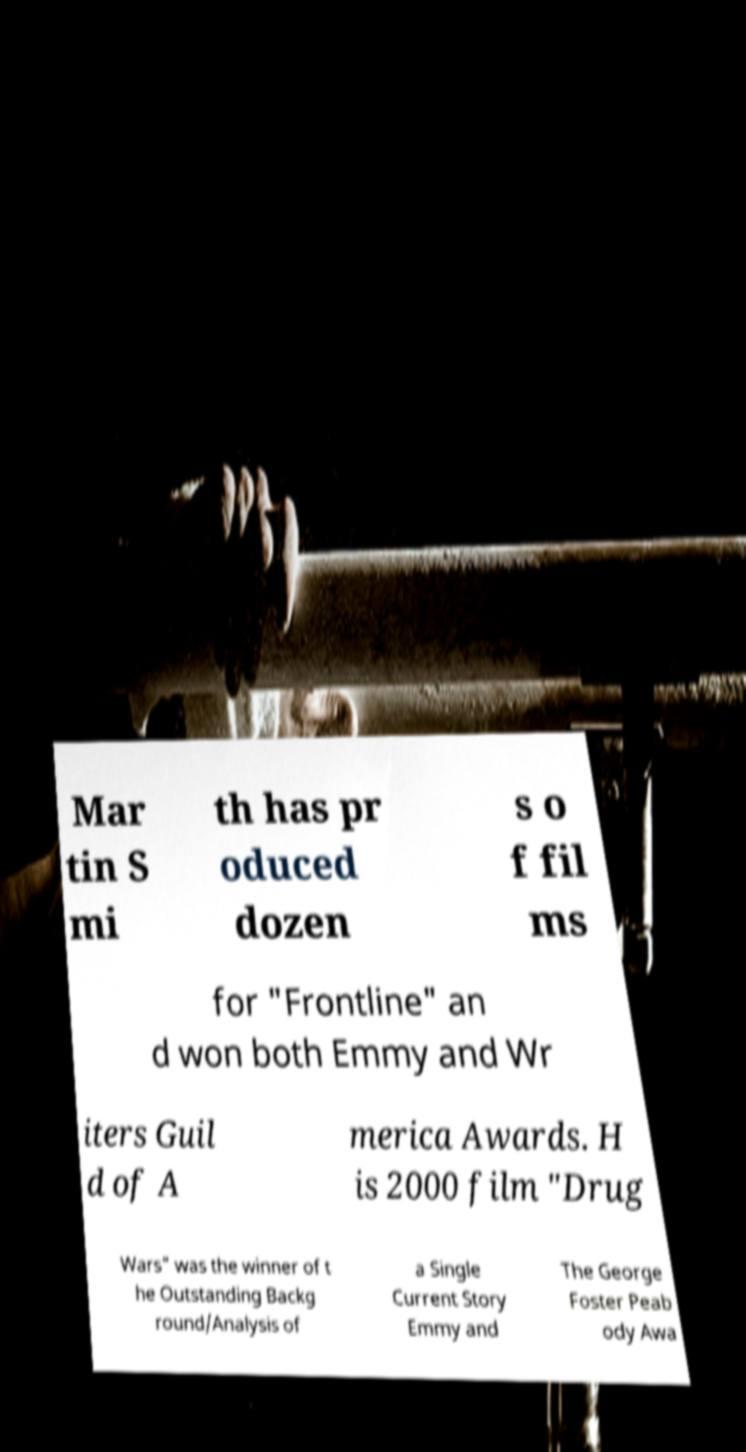Please read and relay the text visible in this image. What does it say? Mar tin S mi th has pr oduced dozen s o f fil ms for "Frontline" an d won both Emmy and Wr iters Guil d of A merica Awards. H is 2000 film "Drug Wars" was the winner of t he Outstanding Backg round/Analysis of a Single Current Story Emmy and The George Foster Peab ody Awa 